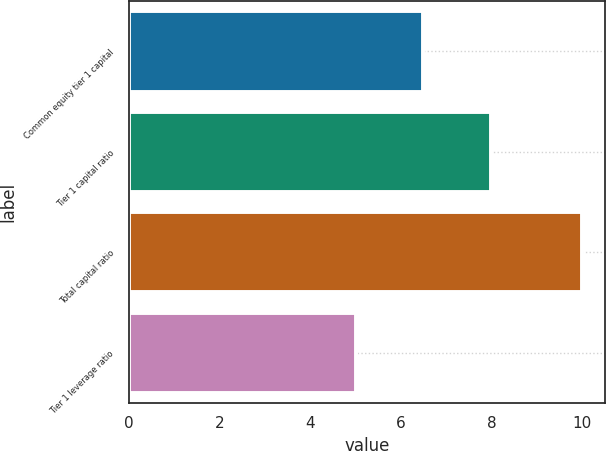Convert chart to OTSL. <chart><loc_0><loc_0><loc_500><loc_500><bar_chart><fcel>Common equity tier 1 capital<fcel>Tier 1 capital ratio<fcel>Total capital ratio<fcel>Tier 1 leverage ratio<nl><fcel>6.5<fcel>8<fcel>10<fcel>5<nl></chart> 